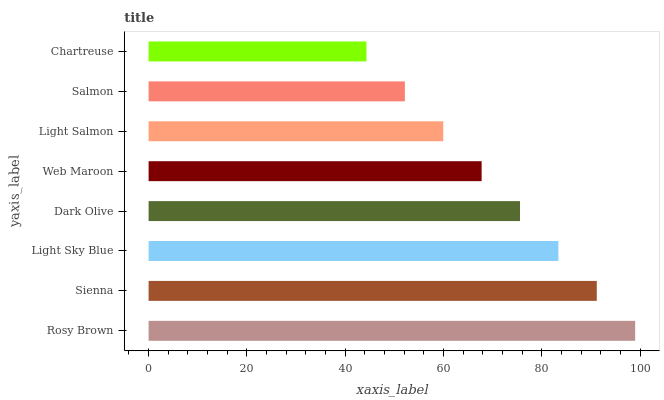Is Chartreuse the minimum?
Answer yes or no. Yes. Is Rosy Brown the maximum?
Answer yes or no. Yes. Is Sienna the minimum?
Answer yes or no. No. Is Sienna the maximum?
Answer yes or no. No. Is Rosy Brown greater than Sienna?
Answer yes or no. Yes. Is Sienna less than Rosy Brown?
Answer yes or no. Yes. Is Sienna greater than Rosy Brown?
Answer yes or no. No. Is Rosy Brown less than Sienna?
Answer yes or no. No. Is Dark Olive the high median?
Answer yes or no. Yes. Is Web Maroon the low median?
Answer yes or no. Yes. Is Light Salmon the high median?
Answer yes or no. No. Is Salmon the low median?
Answer yes or no. No. 